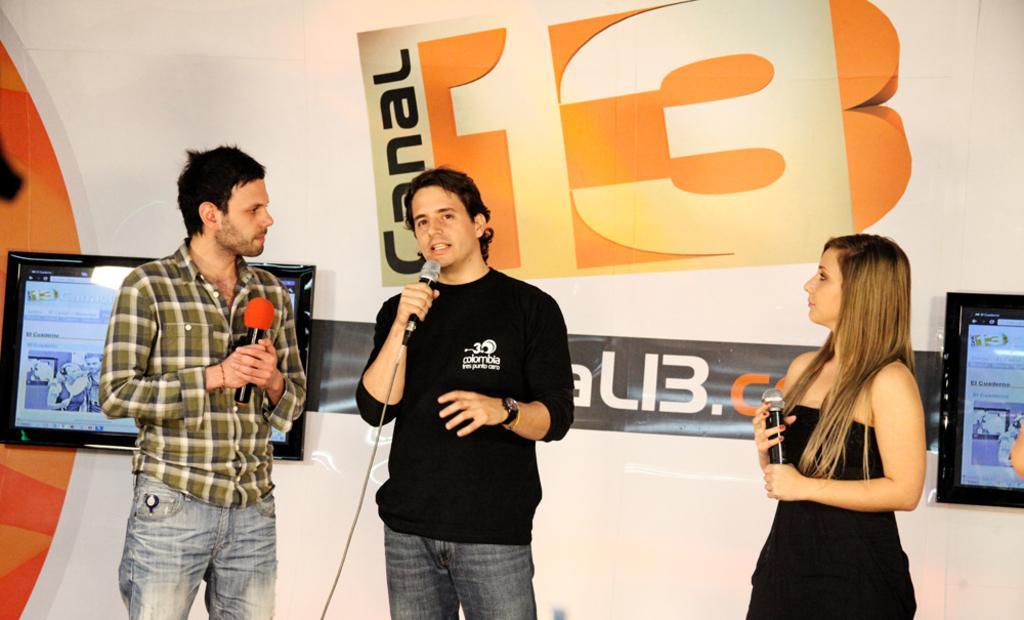How would you summarize this image in a sentence or two? In this image we can see people standing and holding mics in their hands. In the background there are display screens and an advertisement. 